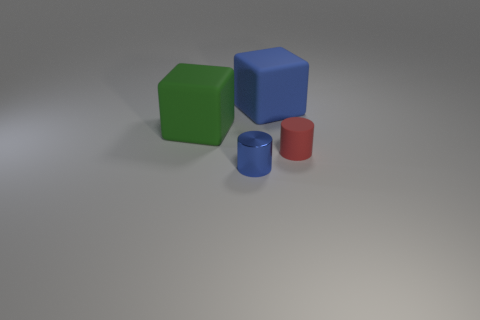How many matte objects are left of the red matte cylinder right of the green cube?
Give a very brief answer. 2. There is a object that is behind the tiny blue cylinder and left of the blue rubber thing; what material is it made of?
Provide a succinct answer. Rubber. There is a red thing behind the blue metallic cylinder; is its shape the same as the small shiny object?
Your answer should be very brief. Yes. Is the number of big blue cubes less than the number of big red metal cylinders?
Provide a short and direct response. No. How many cubes have the same color as the matte cylinder?
Your response must be concise. 0. There is a small metallic thing; is its color the same as the cube to the right of the blue metal thing?
Keep it short and to the point. Yes. Are there more tiny red cylinders than brown objects?
Your response must be concise. Yes. What size is the blue object that is the same shape as the tiny red matte object?
Offer a very short reply. Small. Do the blue block and the blue thing in front of the big blue object have the same material?
Provide a short and direct response. No. What number of things are metal cylinders or red objects?
Offer a very short reply. 2. 